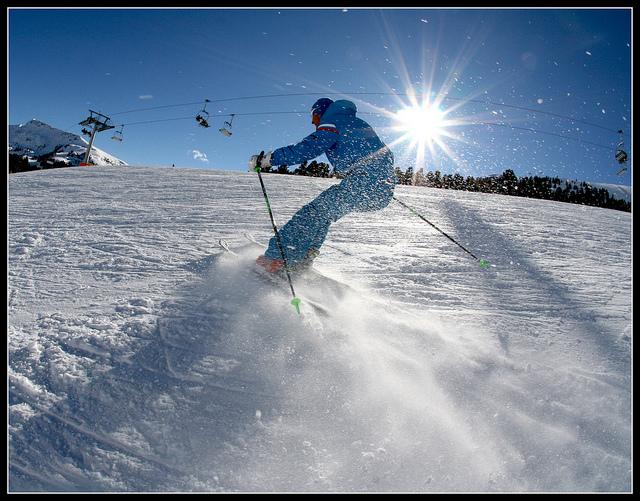What are the wires in the background for?
Answer briefly. Ski lift. Is it a cloudy day?
Be succinct. No. Is this skier wearing a helmet?
Give a very brief answer. No. Is it probably cold here?
Answer briefly. Yes. What color coat does the person have on?
Give a very brief answer. Blue. Where is the sun?
Short answer required. In sky. Is the sun obstructed?
Give a very brief answer. No. 